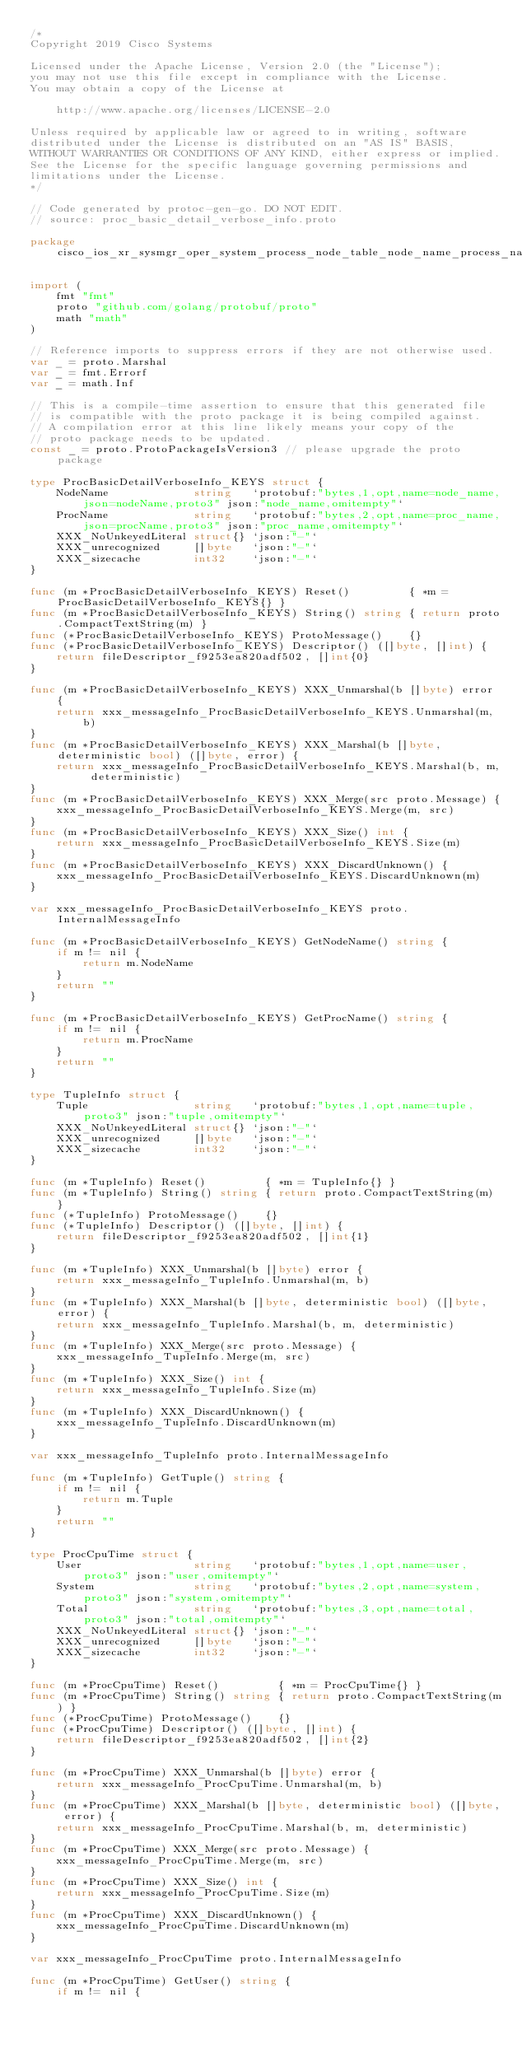Convert code to text. <code><loc_0><loc_0><loc_500><loc_500><_Go_>/*
Copyright 2019 Cisco Systems

Licensed under the Apache License, Version 2.0 (the "License");
you may not use this file except in compliance with the License.
You may obtain a copy of the License at

    http://www.apache.org/licenses/LICENSE-2.0

Unless required by applicable law or agreed to in writing, software
distributed under the License is distributed on an "AS IS" BASIS,
WITHOUT WARRANTIES OR CONDITIONS OF ANY KIND, either express or implied.
See the License for the specific language governing permissions and
limitations under the License.
*/

// Code generated by protoc-gen-go. DO NOT EDIT.
// source: proc_basic_detail_verbose_info.proto

package cisco_ios_xr_sysmgr_oper_system_process_node_table_node_name_process_name_runverboses_process_name_runverbose

import (
	fmt "fmt"
	proto "github.com/golang/protobuf/proto"
	math "math"
)

// Reference imports to suppress errors if they are not otherwise used.
var _ = proto.Marshal
var _ = fmt.Errorf
var _ = math.Inf

// This is a compile-time assertion to ensure that this generated file
// is compatible with the proto package it is being compiled against.
// A compilation error at this line likely means your copy of the
// proto package needs to be updated.
const _ = proto.ProtoPackageIsVersion3 // please upgrade the proto package

type ProcBasicDetailVerboseInfo_KEYS struct {
	NodeName             string   `protobuf:"bytes,1,opt,name=node_name,json=nodeName,proto3" json:"node_name,omitempty"`
	ProcName             string   `protobuf:"bytes,2,opt,name=proc_name,json=procName,proto3" json:"proc_name,omitempty"`
	XXX_NoUnkeyedLiteral struct{} `json:"-"`
	XXX_unrecognized     []byte   `json:"-"`
	XXX_sizecache        int32    `json:"-"`
}

func (m *ProcBasicDetailVerboseInfo_KEYS) Reset()         { *m = ProcBasicDetailVerboseInfo_KEYS{} }
func (m *ProcBasicDetailVerboseInfo_KEYS) String() string { return proto.CompactTextString(m) }
func (*ProcBasicDetailVerboseInfo_KEYS) ProtoMessage()    {}
func (*ProcBasicDetailVerboseInfo_KEYS) Descriptor() ([]byte, []int) {
	return fileDescriptor_f9253ea820adf502, []int{0}
}

func (m *ProcBasicDetailVerboseInfo_KEYS) XXX_Unmarshal(b []byte) error {
	return xxx_messageInfo_ProcBasicDetailVerboseInfo_KEYS.Unmarshal(m, b)
}
func (m *ProcBasicDetailVerboseInfo_KEYS) XXX_Marshal(b []byte, deterministic bool) ([]byte, error) {
	return xxx_messageInfo_ProcBasicDetailVerboseInfo_KEYS.Marshal(b, m, deterministic)
}
func (m *ProcBasicDetailVerboseInfo_KEYS) XXX_Merge(src proto.Message) {
	xxx_messageInfo_ProcBasicDetailVerboseInfo_KEYS.Merge(m, src)
}
func (m *ProcBasicDetailVerboseInfo_KEYS) XXX_Size() int {
	return xxx_messageInfo_ProcBasicDetailVerboseInfo_KEYS.Size(m)
}
func (m *ProcBasicDetailVerboseInfo_KEYS) XXX_DiscardUnknown() {
	xxx_messageInfo_ProcBasicDetailVerboseInfo_KEYS.DiscardUnknown(m)
}

var xxx_messageInfo_ProcBasicDetailVerboseInfo_KEYS proto.InternalMessageInfo

func (m *ProcBasicDetailVerboseInfo_KEYS) GetNodeName() string {
	if m != nil {
		return m.NodeName
	}
	return ""
}

func (m *ProcBasicDetailVerboseInfo_KEYS) GetProcName() string {
	if m != nil {
		return m.ProcName
	}
	return ""
}

type TupleInfo struct {
	Tuple                string   `protobuf:"bytes,1,opt,name=tuple,proto3" json:"tuple,omitempty"`
	XXX_NoUnkeyedLiteral struct{} `json:"-"`
	XXX_unrecognized     []byte   `json:"-"`
	XXX_sizecache        int32    `json:"-"`
}

func (m *TupleInfo) Reset()         { *m = TupleInfo{} }
func (m *TupleInfo) String() string { return proto.CompactTextString(m) }
func (*TupleInfo) ProtoMessage()    {}
func (*TupleInfo) Descriptor() ([]byte, []int) {
	return fileDescriptor_f9253ea820adf502, []int{1}
}

func (m *TupleInfo) XXX_Unmarshal(b []byte) error {
	return xxx_messageInfo_TupleInfo.Unmarshal(m, b)
}
func (m *TupleInfo) XXX_Marshal(b []byte, deterministic bool) ([]byte, error) {
	return xxx_messageInfo_TupleInfo.Marshal(b, m, deterministic)
}
func (m *TupleInfo) XXX_Merge(src proto.Message) {
	xxx_messageInfo_TupleInfo.Merge(m, src)
}
func (m *TupleInfo) XXX_Size() int {
	return xxx_messageInfo_TupleInfo.Size(m)
}
func (m *TupleInfo) XXX_DiscardUnknown() {
	xxx_messageInfo_TupleInfo.DiscardUnknown(m)
}

var xxx_messageInfo_TupleInfo proto.InternalMessageInfo

func (m *TupleInfo) GetTuple() string {
	if m != nil {
		return m.Tuple
	}
	return ""
}

type ProcCpuTime struct {
	User                 string   `protobuf:"bytes,1,opt,name=user,proto3" json:"user,omitempty"`
	System               string   `protobuf:"bytes,2,opt,name=system,proto3" json:"system,omitempty"`
	Total                string   `protobuf:"bytes,3,opt,name=total,proto3" json:"total,omitempty"`
	XXX_NoUnkeyedLiteral struct{} `json:"-"`
	XXX_unrecognized     []byte   `json:"-"`
	XXX_sizecache        int32    `json:"-"`
}

func (m *ProcCpuTime) Reset()         { *m = ProcCpuTime{} }
func (m *ProcCpuTime) String() string { return proto.CompactTextString(m) }
func (*ProcCpuTime) ProtoMessage()    {}
func (*ProcCpuTime) Descriptor() ([]byte, []int) {
	return fileDescriptor_f9253ea820adf502, []int{2}
}

func (m *ProcCpuTime) XXX_Unmarshal(b []byte) error {
	return xxx_messageInfo_ProcCpuTime.Unmarshal(m, b)
}
func (m *ProcCpuTime) XXX_Marshal(b []byte, deterministic bool) ([]byte, error) {
	return xxx_messageInfo_ProcCpuTime.Marshal(b, m, deterministic)
}
func (m *ProcCpuTime) XXX_Merge(src proto.Message) {
	xxx_messageInfo_ProcCpuTime.Merge(m, src)
}
func (m *ProcCpuTime) XXX_Size() int {
	return xxx_messageInfo_ProcCpuTime.Size(m)
}
func (m *ProcCpuTime) XXX_DiscardUnknown() {
	xxx_messageInfo_ProcCpuTime.DiscardUnknown(m)
}

var xxx_messageInfo_ProcCpuTime proto.InternalMessageInfo

func (m *ProcCpuTime) GetUser() string {
	if m != nil {</code> 